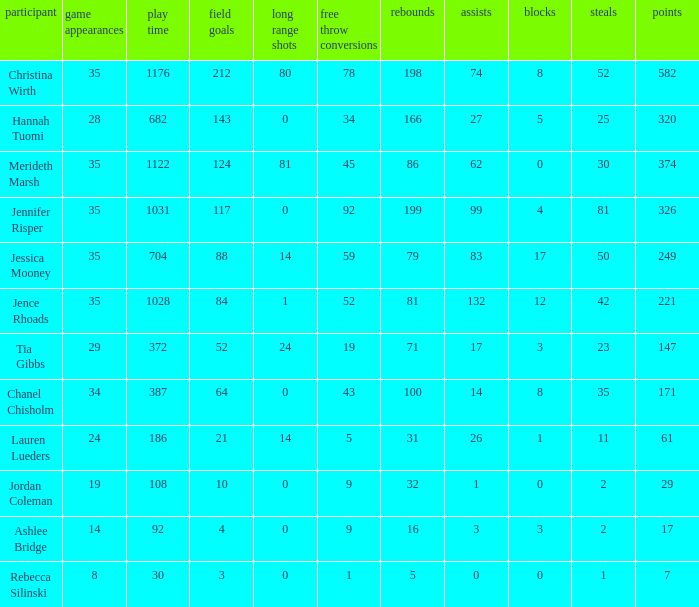How many blockings occured in the game with 198 rebounds? 8.0. 